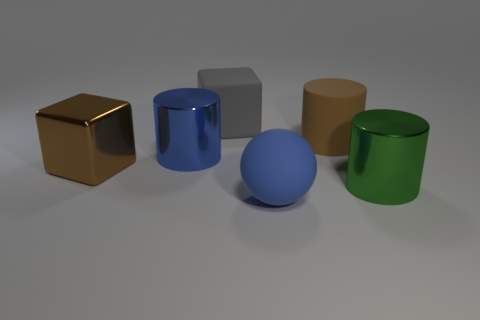Subtract all cyan cylinders. Subtract all blue blocks. How many cylinders are left? 3 Add 3 blue shiny cylinders. How many objects exist? 9 Subtract all spheres. How many objects are left? 5 Subtract 1 green cylinders. How many objects are left? 5 Subtract all gray blocks. Subtract all brown metal objects. How many objects are left? 4 Add 5 large blocks. How many large blocks are left? 7 Add 4 large red matte spheres. How many large red matte spheres exist? 4 